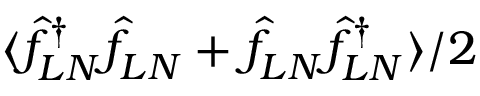Convert formula to latex. <formula><loc_0><loc_0><loc_500><loc_500>\langle \hat { f } _ { L N } ^ { \dagger } \hat { f } _ { L N } + \hat { f } _ { L N } \hat { f } _ { L N } ^ { \dagger } \rangle / 2</formula> 